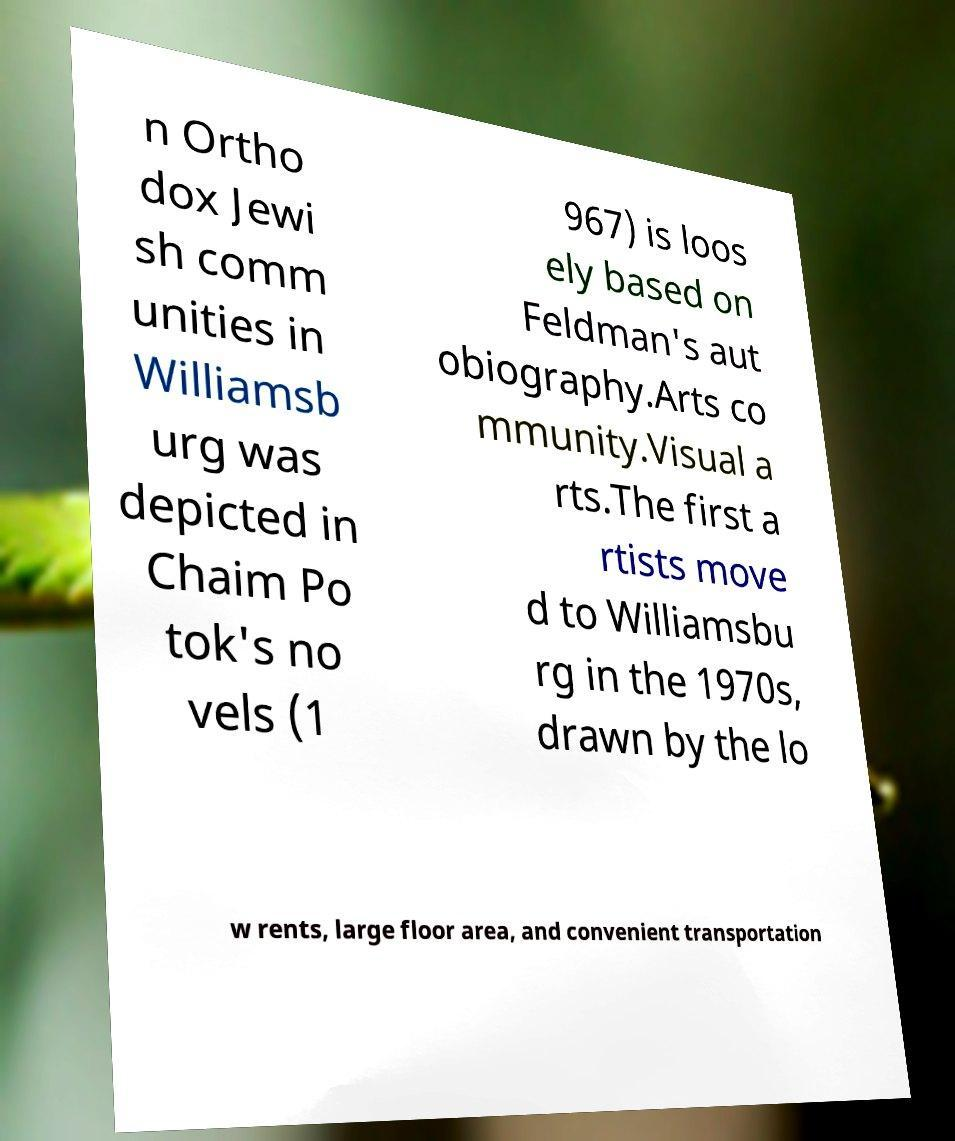Please read and relay the text visible in this image. What does it say? n Ortho dox Jewi sh comm unities in Williamsb urg was depicted in Chaim Po tok's no vels (1 967) is loos ely based on Feldman's aut obiography.Arts co mmunity.Visual a rts.The first a rtists move d to Williamsbu rg in the 1970s, drawn by the lo w rents, large floor area, and convenient transportation 